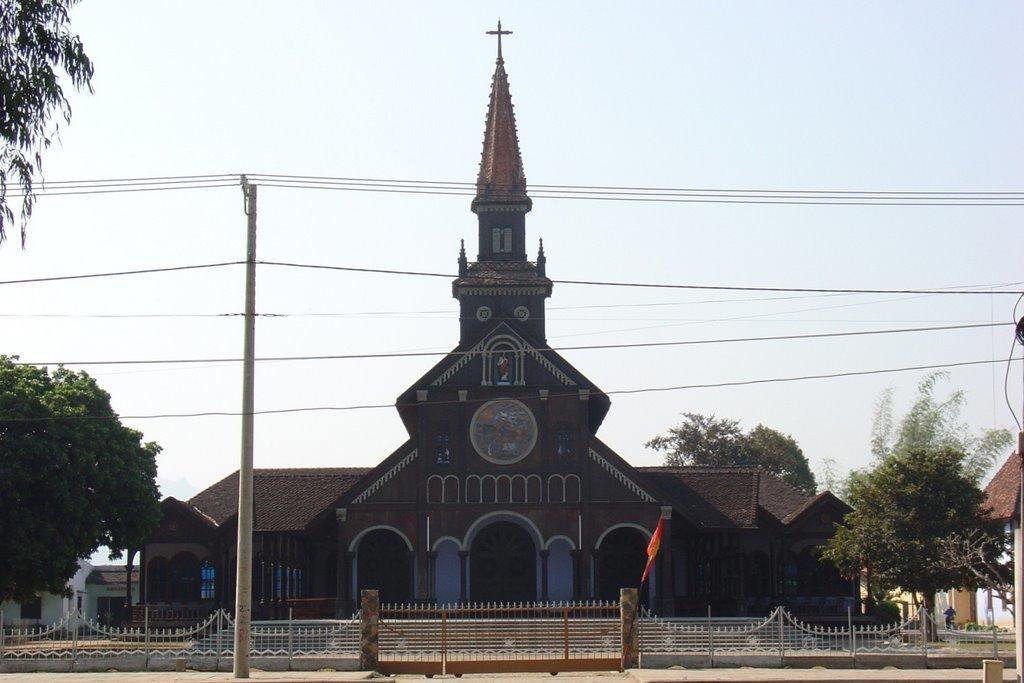Describe this image in one or two sentences. In this picture, we can see a few buildings, trees, person on a bike, gate, fencing, poles, wires and the sky. 